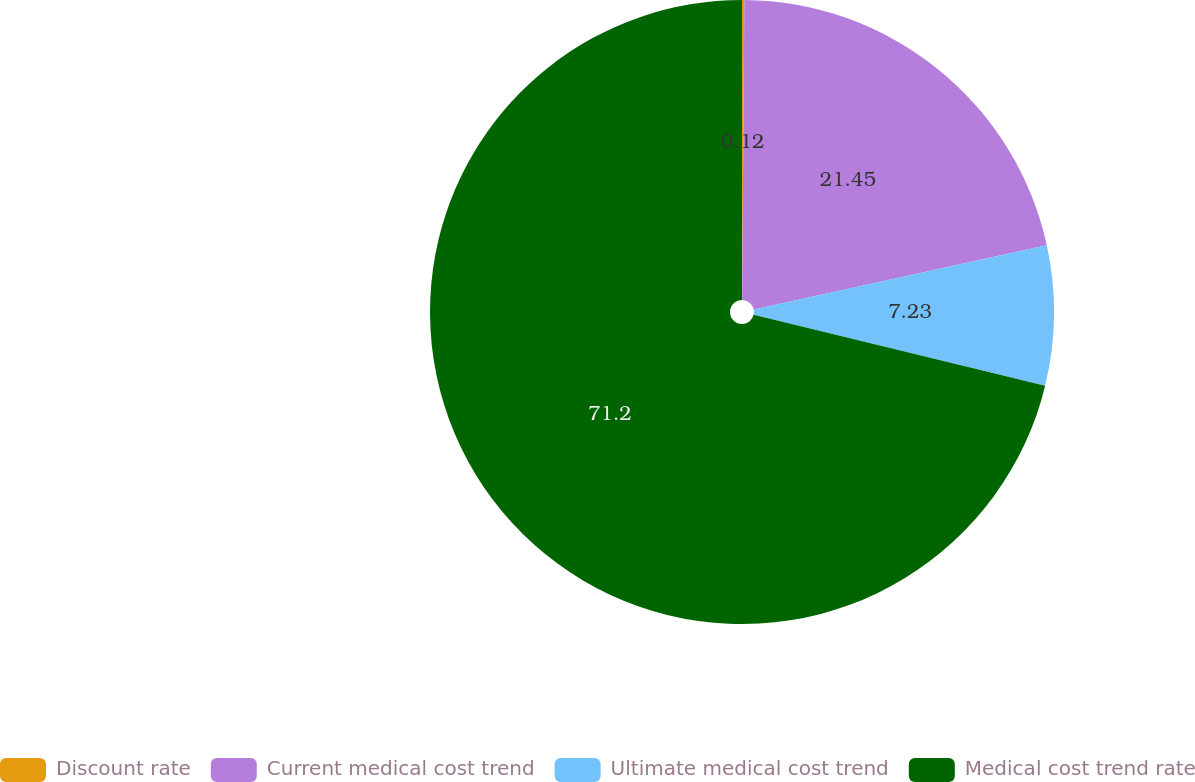Convert chart to OTSL. <chart><loc_0><loc_0><loc_500><loc_500><pie_chart><fcel>Discount rate<fcel>Current medical cost trend<fcel>Ultimate medical cost trend<fcel>Medical cost trend rate<nl><fcel>0.12%<fcel>21.45%<fcel>7.23%<fcel>71.2%<nl></chart> 